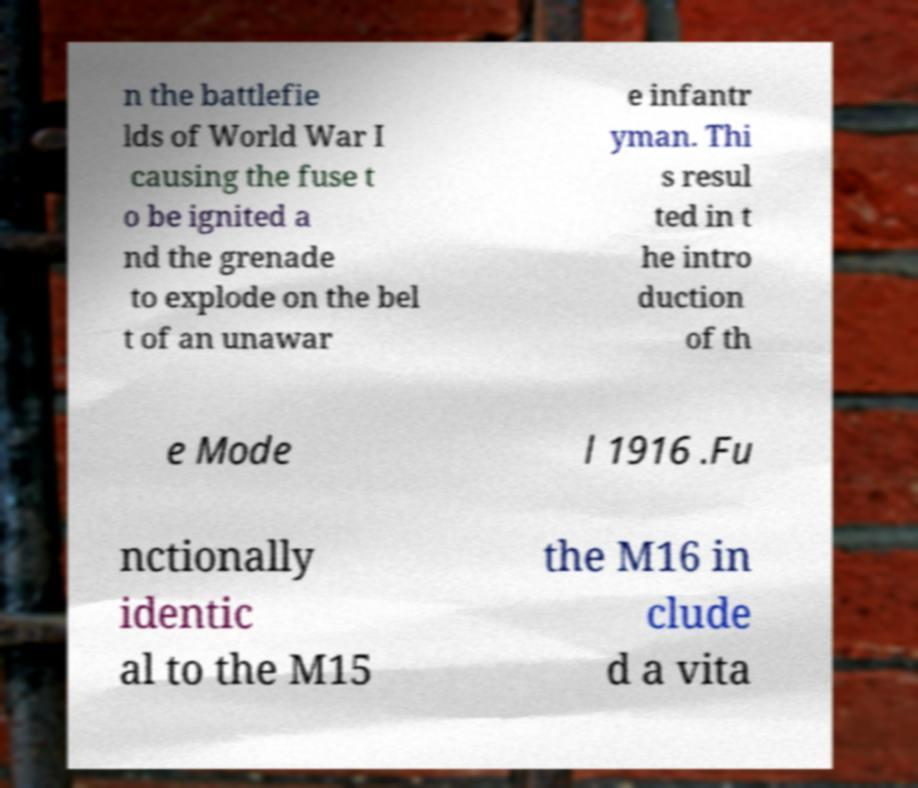Can you accurately transcribe the text from the provided image for me? n the battlefie lds of World War I causing the fuse t o be ignited a nd the grenade to explode on the bel t of an unawar e infantr yman. Thi s resul ted in t he intro duction of th e Mode l 1916 .Fu nctionally identic al to the M15 the M16 in clude d a vita 